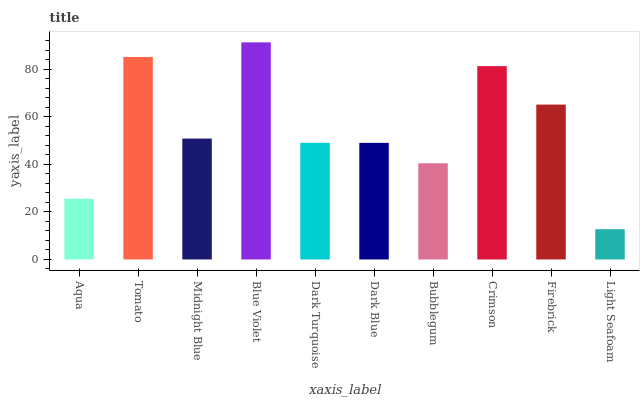Is Light Seafoam the minimum?
Answer yes or no. Yes. Is Blue Violet the maximum?
Answer yes or no. Yes. Is Tomato the minimum?
Answer yes or no. No. Is Tomato the maximum?
Answer yes or no. No. Is Tomato greater than Aqua?
Answer yes or no. Yes. Is Aqua less than Tomato?
Answer yes or no. Yes. Is Aqua greater than Tomato?
Answer yes or no. No. Is Tomato less than Aqua?
Answer yes or no. No. Is Midnight Blue the high median?
Answer yes or no. Yes. Is Dark Turquoise the low median?
Answer yes or no. Yes. Is Bubblegum the high median?
Answer yes or no. No. Is Dark Blue the low median?
Answer yes or no. No. 